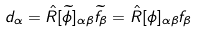Convert formula to latex. <formula><loc_0><loc_0><loc_500><loc_500>d _ { \alpha } = \hat { R } [ \widetilde { \phi } ] _ { \alpha \beta } \widetilde { f } _ { \beta } = \hat { R } [ \phi ] _ { \alpha \beta } f _ { \beta }</formula> 